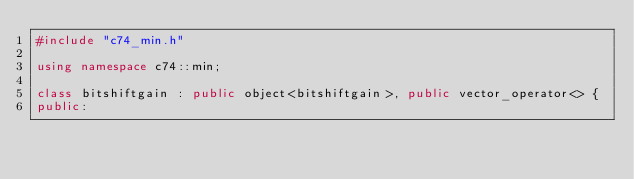<code> <loc_0><loc_0><loc_500><loc_500><_C++_>#include "c74_min.h"

using namespace c74::min;

class bitshiftgain : public object<bitshiftgain>, public vector_operator<> {
public:</code> 